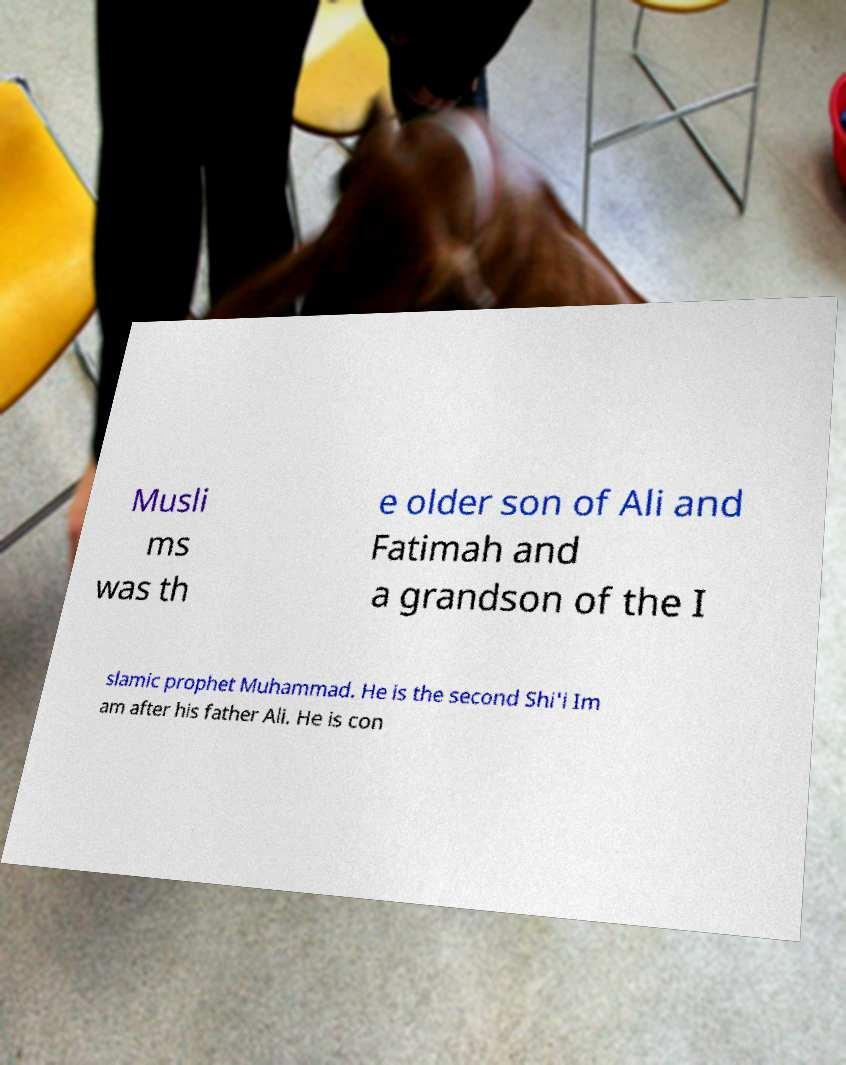I need the written content from this picture converted into text. Can you do that? Musli ms was th e older son of Ali and Fatimah and a grandson of the I slamic prophet Muhammad. He is the second Shi'i Im am after his father Ali. He is con 